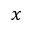<formula> <loc_0><loc_0><loc_500><loc_500>x</formula> 